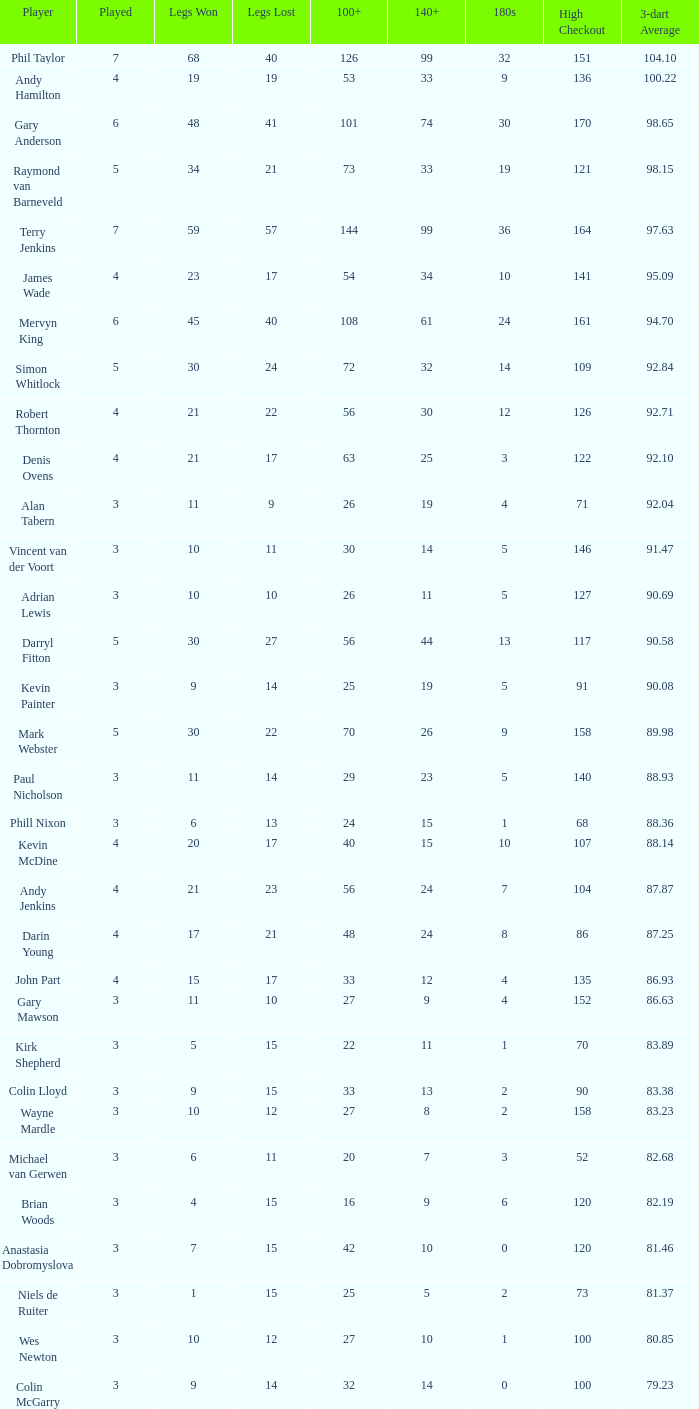Would you be able to parse every entry in this table? {'header': ['Player', 'Played', 'Legs Won', 'Legs Lost', '100+', '140+', '180s', 'High Checkout', '3-dart Average'], 'rows': [['Phil Taylor', '7', '68', '40', '126', '99', '32', '151', '104.10'], ['Andy Hamilton', '4', '19', '19', '53', '33', '9', '136', '100.22'], ['Gary Anderson', '6', '48', '41', '101', '74', '30', '170', '98.65'], ['Raymond van Barneveld', '5', '34', '21', '73', '33', '19', '121', '98.15'], ['Terry Jenkins', '7', '59', '57', '144', '99', '36', '164', '97.63'], ['James Wade', '4', '23', '17', '54', '34', '10', '141', '95.09'], ['Mervyn King', '6', '45', '40', '108', '61', '24', '161', '94.70'], ['Simon Whitlock', '5', '30', '24', '72', '32', '14', '109', '92.84'], ['Robert Thornton', '4', '21', '22', '56', '30', '12', '126', '92.71'], ['Denis Ovens', '4', '21', '17', '63', '25', '3', '122', '92.10'], ['Alan Tabern', '3', '11', '9', '26', '19', '4', '71', '92.04'], ['Vincent van der Voort', '3', '10', '11', '30', '14', '5', '146', '91.47'], ['Adrian Lewis', '3', '10', '10', '26', '11', '5', '127', '90.69'], ['Darryl Fitton', '5', '30', '27', '56', '44', '13', '117', '90.58'], ['Kevin Painter', '3', '9', '14', '25', '19', '5', '91', '90.08'], ['Mark Webster', '5', '30', '22', '70', '26', '9', '158', '89.98'], ['Paul Nicholson', '3', '11', '14', '29', '23', '5', '140', '88.93'], ['Phill Nixon', '3', '6', '13', '24', '15', '1', '68', '88.36'], ['Kevin McDine', '4', '20', '17', '40', '15', '10', '107', '88.14'], ['Andy Jenkins', '4', '21', '23', '56', '24', '7', '104', '87.87'], ['Darin Young', '4', '17', '21', '48', '24', '8', '86', '87.25'], ['John Part', '4', '15', '17', '33', '12', '4', '135', '86.93'], ['Gary Mawson', '3', '11', '10', '27', '9', '4', '152', '86.63'], ['Kirk Shepherd', '3', '5', '15', '22', '11', '1', '70', '83.89'], ['Colin Lloyd', '3', '9', '15', '33', '13', '2', '90', '83.38'], ['Wayne Mardle', '3', '10', '12', '27', '8', '2', '158', '83.23'], ['Michael van Gerwen', '3', '6', '11', '20', '7', '3', '52', '82.68'], ['Brian Woods', '3', '4', '15', '16', '9', '6', '120', '82.19'], ['Anastasia Dobromyslova', '3', '7', '15', '42', '10', '0', '120', '81.46'], ['Niels de Ruiter', '3', '1', '15', '25', '5', '2', '73', '81.37'], ['Wes Newton', '3', '10', '12', '27', '10', '1', '100', '80.85'], ['Colin McGarry', '3', '9', '14', '32', '14', '0', '100', '79.23']]} What is the lowest high checkout when 140+ is 61, and played is larger than 6? None. 